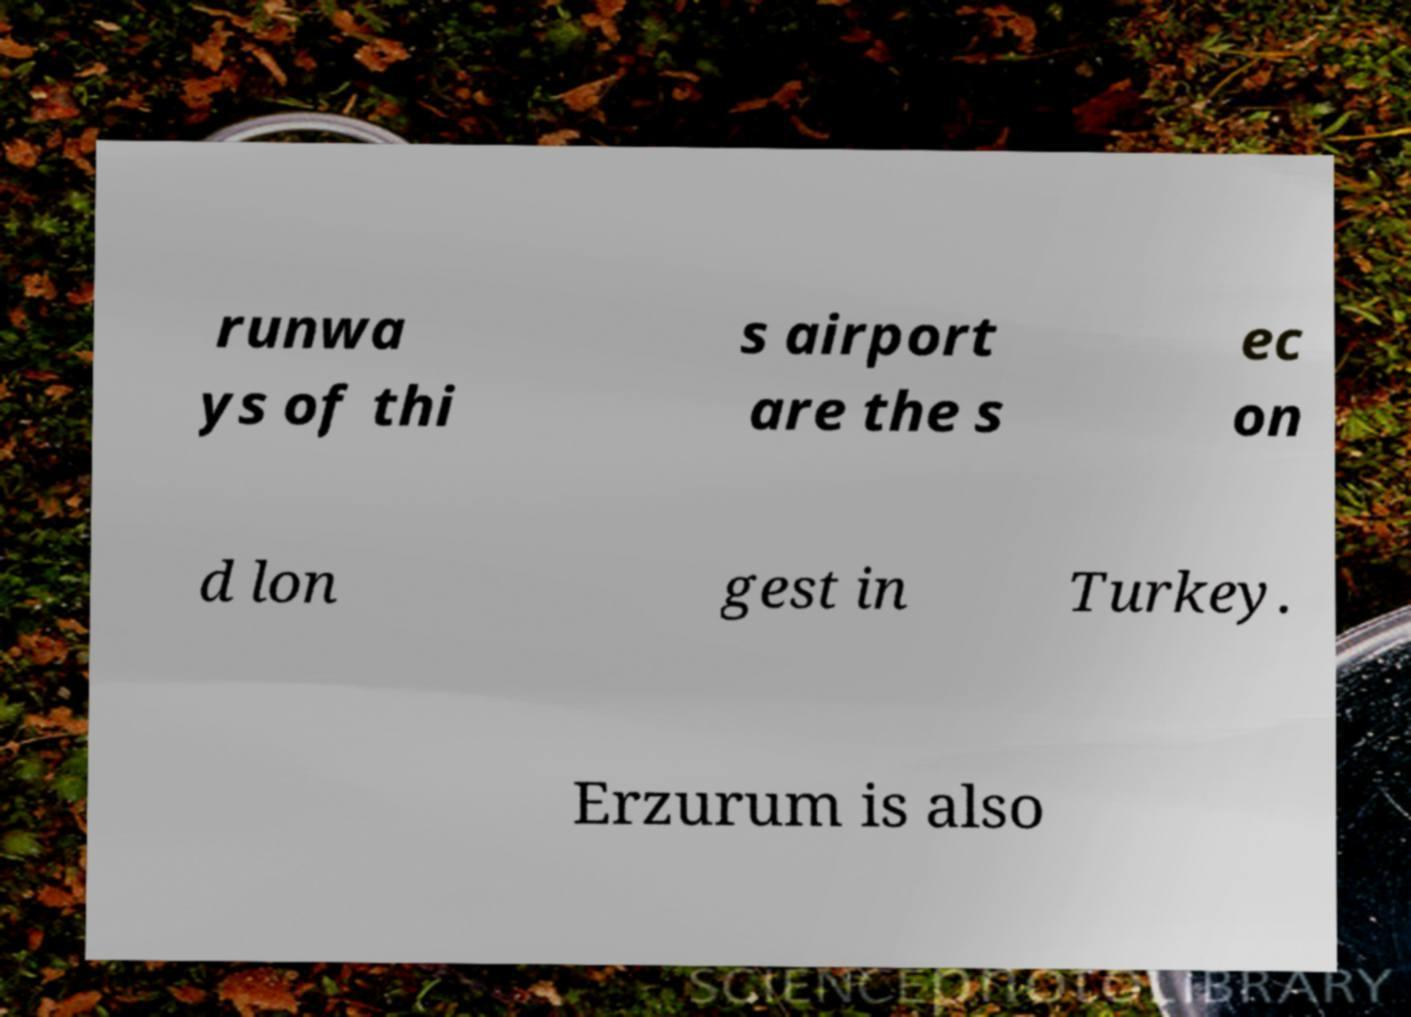There's text embedded in this image that I need extracted. Can you transcribe it verbatim? runwa ys of thi s airport are the s ec on d lon gest in Turkey. Erzurum is also 